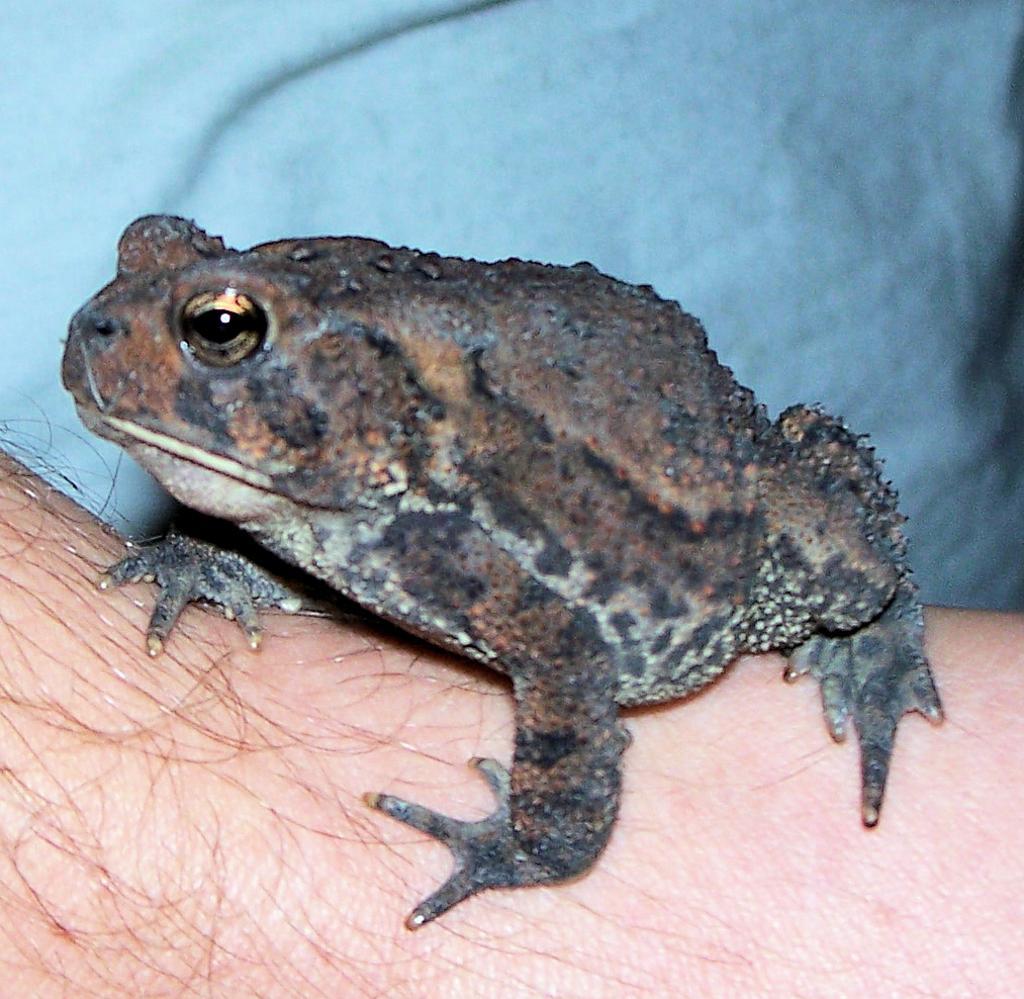Please provide a concise description of this image. In this image I see a frog on the skin which is of cream in color and I see the hairs and I see the blue color cloth in the background. 